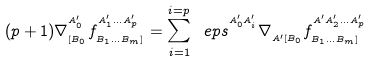Convert formula to latex. <formula><loc_0><loc_0><loc_500><loc_500>( p + 1 ) \nabla _ { _ { [ B _ { 0 } } } ^ { ^ { A ^ { \prime } _ { 0 } } } f _ { _ { B _ { 1 } \dots B _ { m } ] } } ^ { ^ { A ^ { \prime } _ { 1 } \dots A ^ { \prime } _ { p } } } = \sum _ { i = 1 } ^ { i = p } \ e p s ^ { ^ { A ^ { \prime } _ { 0 } A ^ { \prime } _ { i } } } \nabla _ { _ { A ^ { \prime } [ B _ { 0 } } } f _ { _ { B _ { 1 } \dots B _ { m } ] } } ^ { ^ { A ^ { \prime } A ^ { \prime } _ { 2 } \dots A ^ { \prime } _ { p } } }</formula> 